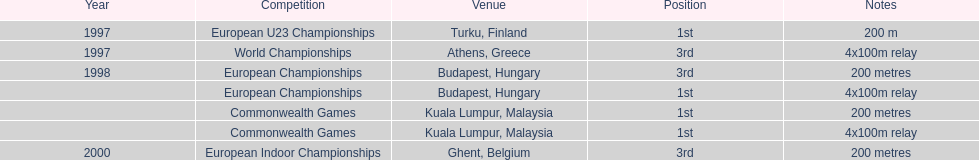Itemize the events that feature the same relay as world championships originating from athens, greece. European Championships, Commonwealth Games. 